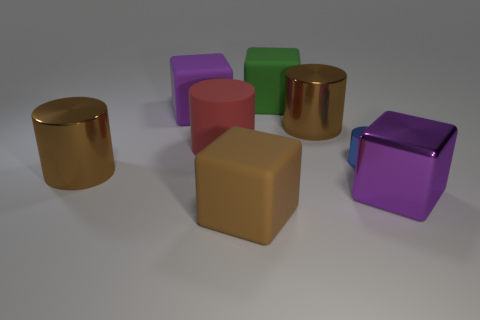Subtract all red blocks. Subtract all brown cylinders. How many blocks are left? 4 Add 1 large objects. How many objects exist? 9 Add 1 big blocks. How many big blocks are left? 5 Add 7 big brown objects. How many big brown objects exist? 10 Subtract 1 red cylinders. How many objects are left? 7 Subtract all brown cubes. Subtract all big rubber cubes. How many objects are left? 4 